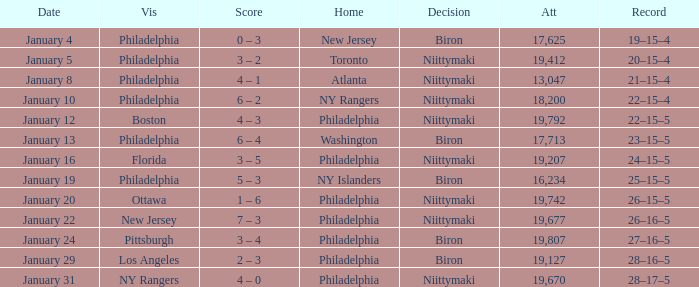Which team was the visitor on January 10? Philadelphia. 